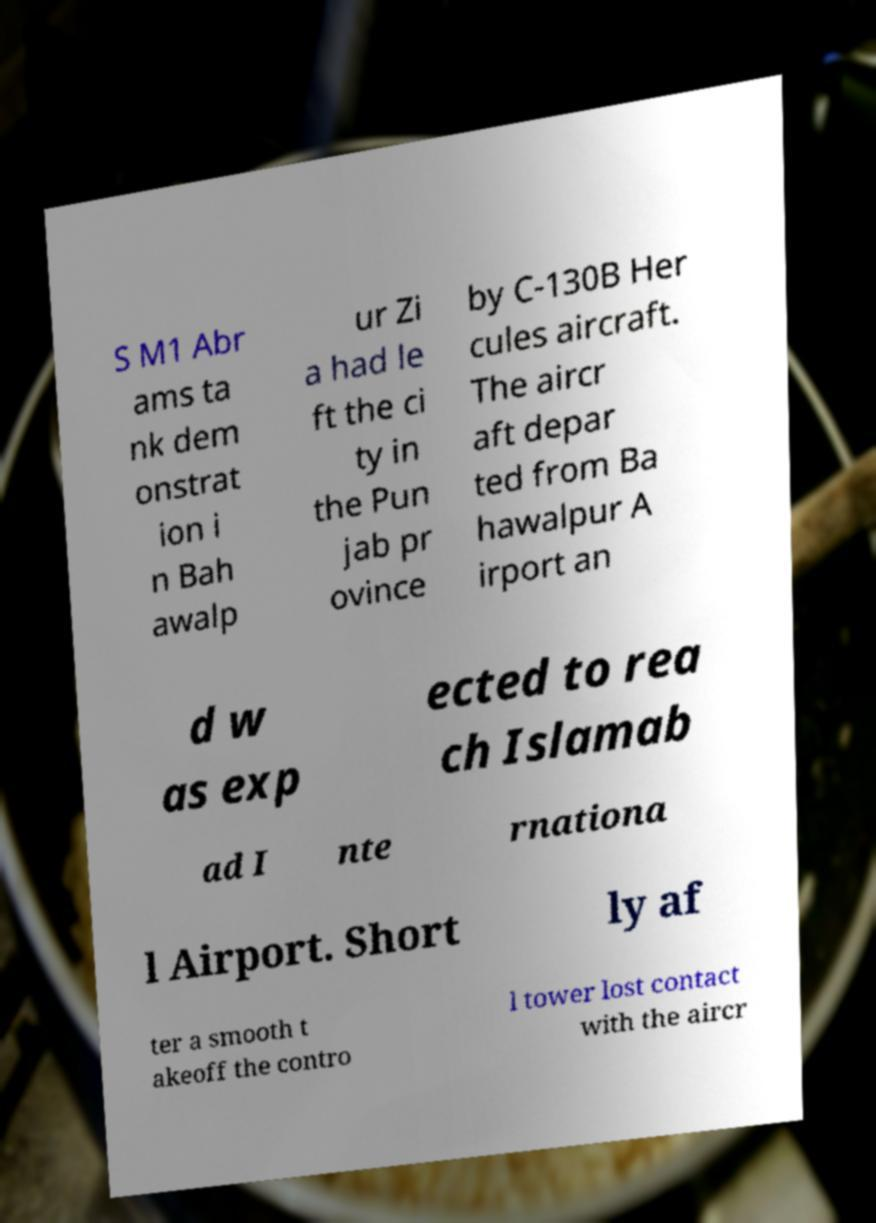Please identify and transcribe the text found in this image. S M1 Abr ams ta nk dem onstrat ion i n Bah awalp ur Zi a had le ft the ci ty in the Pun jab pr ovince by C-130B Her cules aircraft. The aircr aft depar ted from Ba hawalpur A irport an d w as exp ected to rea ch Islamab ad I nte rnationa l Airport. Short ly af ter a smooth t akeoff the contro l tower lost contact with the aircr 